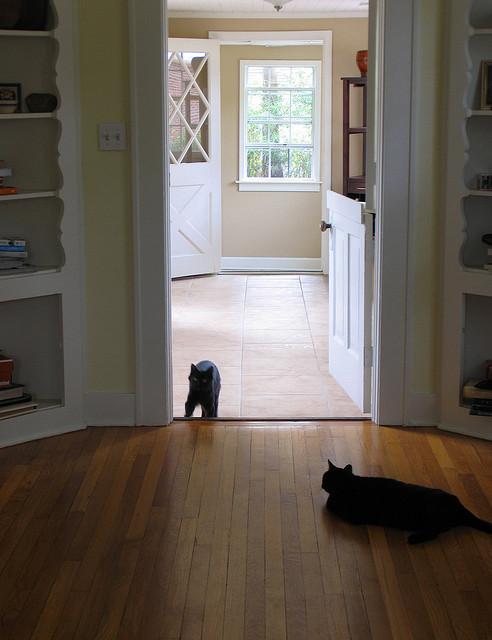Does it look like there is some trepidation on the part of the approaching cat?
Be succinct. Yes. Is the room dark?
Quick response, please. Yes. Is the room empty?
Quick response, please. No. What is the little animal in the doorway?
Write a very short answer. Cat. 